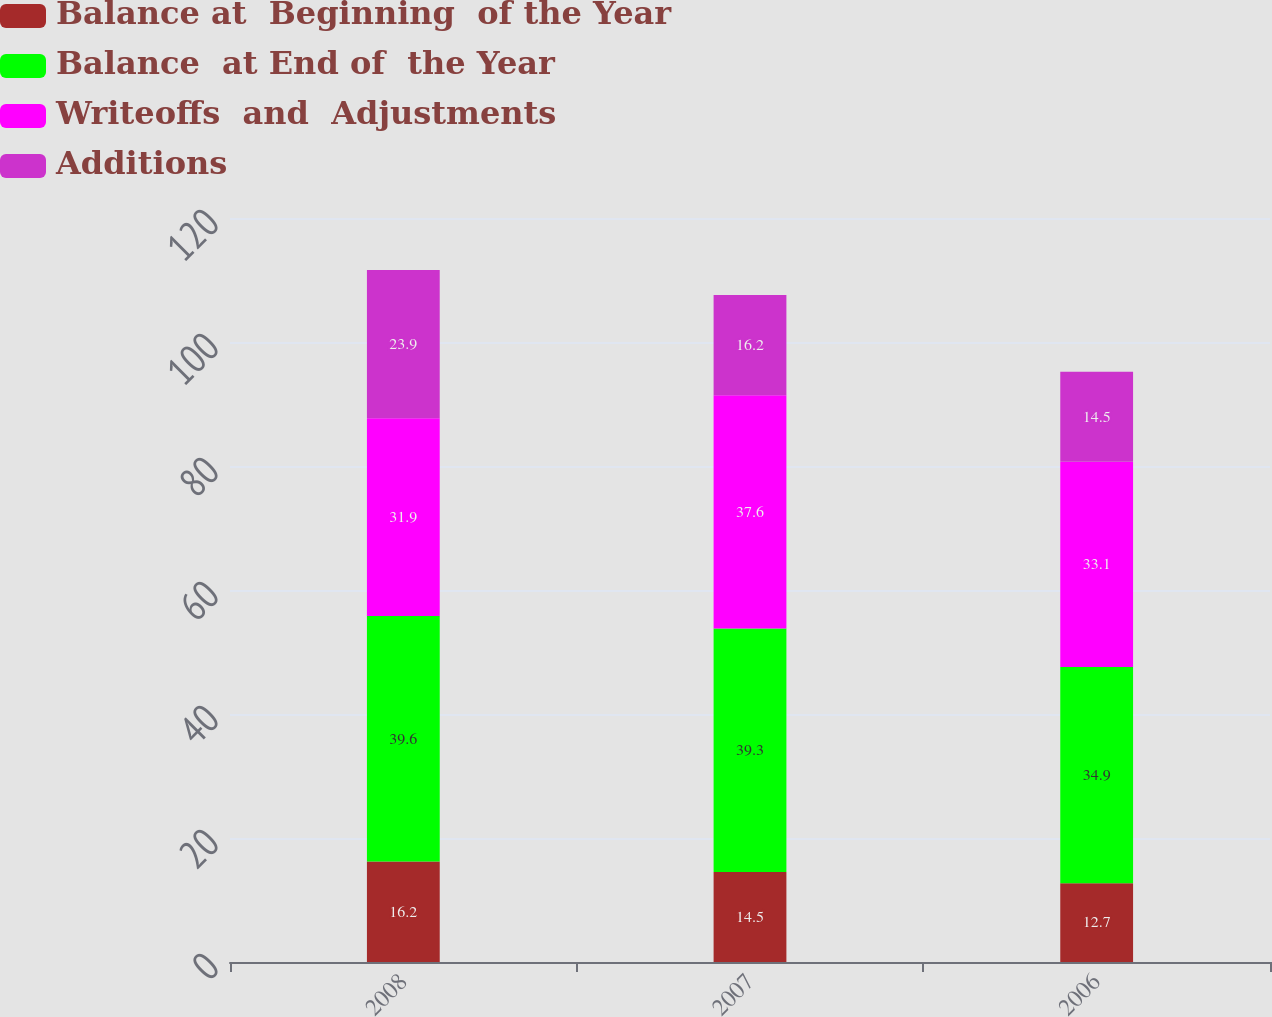Convert chart. <chart><loc_0><loc_0><loc_500><loc_500><stacked_bar_chart><ecel><fcel>2008<fcel>2007<fcel>2006<nl><fcel>Balance at  Beginning  of the Year<fcel>16.2<fcel>14.5<fcel>12.7<nl><fcel>Balance  at End of  the Year<fcel>39.6<fcel>39.3<fcel>34.9<nl><fcel>Writeoffs  and  Adjustments<fcel>31.9<fcel>37.6<fcel>33.1<nl><fcel>Additions<fcel>23.9<fcel>16.2<fcel>14.5<nl></chart> 